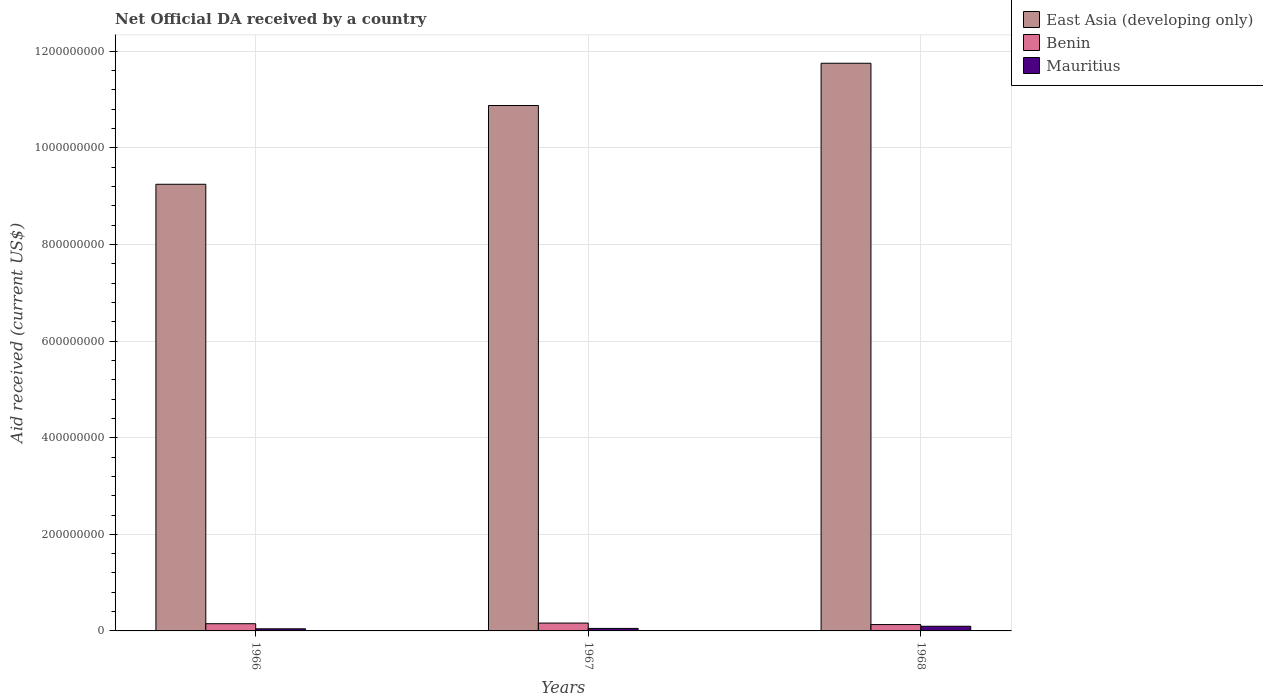How many groups of bars are there?
Offer a very short reply. 3. Are the number of bars per tick equal to the number of legend labels?
Ensure brevity in your answer.  Yes. How many bars are there on the 1st tick from the left?
Offer a very short reply. 3. What is the label of the 2nd group of bars from the left?
Give a very brief answer. 1967. What is the net official development assistance aid received in Mauritius in 1966?
Keep it short and to the point. 4.38e+06. Across all years, what is the maximum net official development assistance aid received in East Asia (developing only)?
Keep it short and to the point. 1.18e+09. Across all years, what is the minimum net official development assistance aid received in Mauritius?
Make the answer very short. 4.38e+06. In which year was the net official development assistance aid received in East Asia (developing only) maximum?
Give a very brief answer. 1968. In which year was the net official development assistance aid received in East Asia (developing only) minimum?
Your answer should be compact. 1966. What is the total net official development assistance aid received in Mauritius in the graph?
Keep it short and to the point. 1.92e+07. What is the difference between the net official development assistance aid received in Benin in 1966 and that in 1967?
Your response must be concise. -1.35e+06. What is the difference between the net official development assistance aid received in East Asia (developing only) in 1968 and the net official development assistance aid received in Mauritius in 1967?
Offer a terse response. 1.17e+09. What is the average net official development assistance aid received in East Asia (developing only) per year?
Your response must be concise. 1.06e+09. In the year 1966, what is the difference between the net official development assistance aid received in Benin and net official development assistance aid received in Mauritius?
Provide a short and direct response. 1.05e+07. In how many years, is the net official development assistance aid received in Benin greater than 720000000 US$?
Keep it short and to the point. 0. What is the ratio of the net official development assistance aid received in Benin in 1967 to that in 1968?
Your answer should be compact. 1.24. Is the net official development assistance aid received in East Asia (developing only) in 1966 less than that in 1967?
Your answer should be compact. Yes. Is the difference between the net official development assistance aid received in Benin in 1967 and 1968 greater than the difference between the net official development assistance aid received in Mauritius in 1967 and 1968?
Give a very brief answer. Yes. What is the difference between the highest and the second highest net official development assistance aid received in Benin?
Provide a succinct answer. 1.35e+06. What is the difference between the highest and the lowest net official development assistance aid received in Benin?
Provide a short and direct response. 3.13e+06. In how many years, is the net official development assistance aid received in Benin greater than the average net official development assistance aid received in Benin taken over all years?
Provide a succinct answer. 2. What does the 3rd bar from the left in 1967 represents?
Provide a short and direct response. Mauritius. What does the 2nd bar from the right in 1968 represents?
Your answer should be very brief. Benin. How many bars are there?
Offer a terse response. 9. Does the graph contain any zero values?
Provide a succinct answer. No. Does the graph contain grids?
Your answer should be compact. Yes. Where does the legend appear in the graph?
Your answer should be compact. Top right. What is the title of the graph?
Ensure brevity in your answer.  Net Official DA received by a country. Does "Namibia" appear as one of the legend labels in the graph?
Offer a terse response. No. What is the label or title of the X-axis?
Provide a short and direct response. Years. What is the label or title of the Y-axis?
Your answer should be very brief. Aid received (current US$). What is the Aid received (current US$) in East Asia (developing only) in 1966?
Provide a short and direct response. 9.25e+08. What is the Aid received (current US$) in Benin in 1966?
Provide a short and direct response. 1.49e+07. What is the Aid received (current US$) in Mauritius in 1966?
Offer a terse response. 4.38e+06. What is the Aid received (current US$) in East Asia (developing only) in 1967?
Keep it short and to the point. 1.09e+09. What is the Aid received (current US$) of Benin in 1967?
Provide a short and direct response. 1.63e+07. What is the Aid received (current US$) of Mauritius in 1967?
Your response must be concise. 5.18e+06. What is the Aid received (current US$) of East Asia (developing only) in 1968?
Give a very brief answer. 1.18e+09. What is the Aid received (current US$) in Benin in 1968?
Ensure brevity in your answer.  1.31e+07. What is the Aid received (current US$) of Mauritius in 1968?
Provide a succinct answer. 9.64e+06. Across all years, what is the maximum Aid received (current US$) in East Asia (developing only)?
Ensure brevity in your answer.  1.18e+09. Across all years, what is the maximum Aid received (current US$) of Benin?
Offer a terse response. 1.63e+07. Across all years, what is the maximum Aid received (current US$) in Mauritius?
Offer a very short reply. 9.64e+06. Across all years, what is the minimum Aid received (current US$) in East Asia (developing only)?
Make the answer very short. 9.25e+08. Across all years, what is the minimum Aid received (current US$) of Benin?
Offer a very short reply. 1.31e+07. Across all years, what is the minimum Aid received (current US$) of Mauritius?
Your response must be concise. 4.38e+06. What is the total Aid received (current US$) in East Asia (developing only) in the graph?
Your answer should be very brief. 3.19e+09. What is the total Aid received (current US$) in Benin in the graph?
Offer a terse response. 4.43e+07. What is the total Aid received (current US$) of Mauritius in the graph?
Provide a short and direct response. 1.92e+07. What is the difference between the Aid received (current US$) in East Asia (developing only) in 1966 and that in 1967?
Give a very brief answer. -1.63e+08. What is the difference between the Aid received (current US$) in Benin in 1966 and that in 1967?
Provide a short and direct response. -1.35e+06. What is the difference between the Aid received (current US$) of Mauritius in 1966 and that in 1967?
Offer a terse response. -8.00e+05. What is the difference between the Aid received (current US$) of East Asia (developing only) in 1966 and that in 1968?
Offer a terse response. -2.51e+08. What is the difference between the Aid received (current US$) in Benin in 1966 and that in 1968?
Keep it short and to the point. 1.78e+06. What is the difference between the Aid received (current US$) in Mauritius in 1966 and that in 1968?
Provide a succinct answer. -5.26e+06. What is the difference between the Aid received (current US$) in East Asia (developing only) in 1967 and that in 1968?
Provide a short and direct response. -8.75e+07. What is the difference between the Aid received (current US$) of Benin in 1967 and that in 1968?
Provide a succinct answer. 3.13e+06. What is the difference between the Aid received (current US$) in Mauritius in 1967 and that in 1968?
Give a very brief answer. -4.46e+06. What is the difference between the Aid received (current US$) of East Asia (developing only) in 1966 and the Aid received (current US$) of Benin in 1967?
Make the answer very short. 9.09e+08. What is the difference between the Aid received (current US$) of East Asia (developing only) in 1966 and the Aid received (current US$) of Mauritius in 1967?
Ensure brevity in your answer.  9.20e+08. What is the difference between the Aid received (current US$) of Benin in 1966 and the Aid received (current US$) of Mauritius in 1967?
Offer a very short reply. 9.74e+06. What is the difference between the Aid received (current US$) in East Asia (developing only) in 1966 and the Aid received (current US$) in Benin in 1968?
Offer a terse response. 9.12e+08. What is the difference between the Aid received (current US$) in East Asia (developing only) in 1966 and the Aid received (current US$) in Mauritius in 1968?
Provide a succinct answer. 9.15e+08. What is the difference between the Aid received (current US$) in Benin in 1966 and the Aid received (current US$) in Mauritius in 1968?
Your answer should be very brief. 5.28e+06. What is the difference between the Aid received (current US$) of East Asia (developing only) in 1967 and the Aid received (current US$) of Benin in 1968?
Keep it short and to the point. 1.07e+09. What is the difference between the Aid received (current US$) in East Asia (developing only) in 1967 and the Aid received (current US$) in Mauritius in 1968?
Offer a very short reply. 1.08e+09. What is the difference between the Aid received (current US$) in Benin in 1967 and the Aid received (current US$) in Mauritius in 1968?
Your answer should be compact. 6.63e+06. What is the average Aid received (current US$) in East Asia (developing only) per year?
Keep it short and to the point. 1.06e+09. What is the average Aid received (current US$) in Benin per year?
Make the answer very short. 1.48e+07. What is the average Aid received (current US$) of Mauritius per year?
Keep it short and to the point. 6.40e+06. In the year 1966, what is the difference between the Aid received (current US$) in East Asia (developing only) and Aid received (current US$) in Benin?
Provide a short and direct response. 9.10e+08. In the year 1966, what is the difference between the Aid received (current US$) of East Asia (developing only) and Aid received (current US$) of Mauritius?
Give a very brief answer. 9.20e+08. In the year 1966, what is the difference between the Aid received (current US$) in Benin and Aid received (current US$) in Mauritius?
Keep it short and to the point. 1.05e+07. In the year 1967, what is the difference between the Aid received (current US$) of East Asia (developing only) and Aid received (current US$) of Benin?
Keep it short and to the point. 1.07e+09. In the year 1967, what is the difference between the Aid received (current US$) of East Asia (developing only) and Aid received (current US$) of Mauritius?
Offer a terse response. 1.08e+09. In the year 1967, what is the difference between the Aid received (current US$) in Benin and Aid received (current US$) in Mauritius?
Offer a very short reply. 1.11e+07. In the year 1968, what is the difference between the Aid received (current US$) of East Asia (developing only) and Aid received (current US$) of Benin?
Offer a very short reply. 1.16e+09. In the year 1968, what is the difference between the Aid received (current US$) of East Asia (developing only) and Aid received (current US$) of Mauritius?
Offer a terse response. 1.17e+09. In the year 1968, what is the difference between the Aid received (current US$) in Benin and Aid received (current US$) in Mauritius?
Your answer should be very brief. 3.50e+06. What is the ratio of the Aid received (current US$) in East Asia (developing only) in 1966 to that in 1967?
Your answer should be very brief. 0.85. What is the ratio of the Aid received (current US$) in Benin in 1966 to that in 1967?
Offer a very short reply. 0.92. What is the ratio of the Aid received (current US$) in Mauritius in 1966 to that in 1967?
Your answer should be compact. 0.85. What is the ratio of the Aid received (current US$) in East Asia (developing only) in 1966 to that in 1968?
Keep it short and to the point. 0.79. What is the ratio of the Aid received (current US$) of Benin in 1966 to that in 1968?
Provide a succinct answer. 1.14. What is the ratio of the Aid received (current US$) of Mauritius in 1966 to that in 1968?
Your answer should be very brief. 0.45. What is the ratio of the Aid received (current US$) of East Asia (developing only) in 1967 to that in 1968?
Your answer should be compact. 0.93. What is the ratio of the Aid received (current US$) in Benin in 1967 to that in 1968?
Your response must be concise. 1.24. What is the ratio of the Aid received (current US$) of Mauritius in 1967 to that in 1968?
Your answer should be very brief. 0.54. What is the difference between the highest and the second highest Aid received (current US$) in East Asia (developing only)?
Offer a very short reply. 8.75e+07. What is the difference between the highest and the second highest Aid received (current US$) of Benin?
Keep it short and to the point. 1.35e+06. What is the difference between the highest and the second highest Aid received (current US$) of Mauritius?
Make the answer very short. 4.46e+06. What is the difference between the highest and the lowest Aid received (current US$) of East Asia (developing only)?
Make the answer very short. 2.51e+08. What is the difference between the highest and the lowest Aid received (current US$) in Benin?
Keep it short and to the point. 3.13e+06. What is the difference between the highest and the lowest Aid received (current US$) in Mauritius?
Keep it short and to the point. 5.26e+06. 